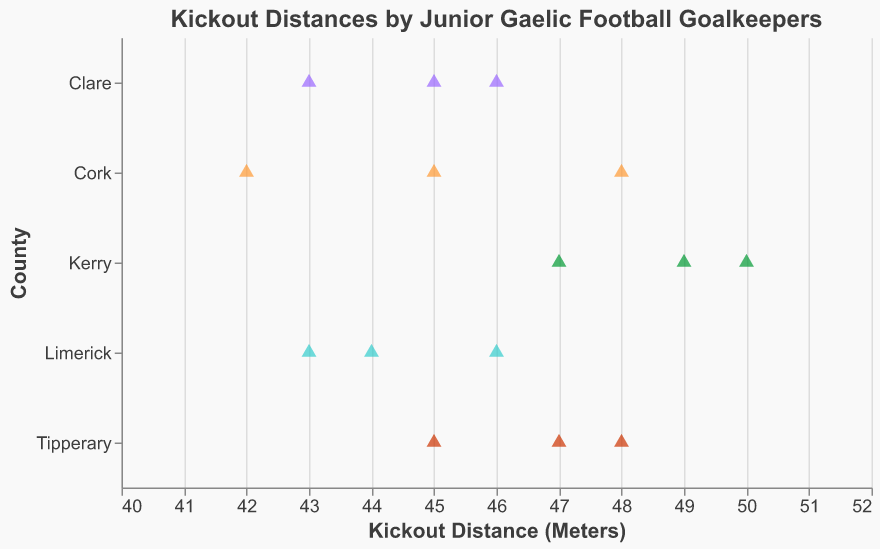What is the title of the figure? The title is located at the top of the figure and it typically describes the content of the plot. In this plot, the title is "Kickout Distances by Junior Gaelic Football Goalkeepers".
Answer: Kickout Distances by Junior Gaelic Football Goalkeepers Which goalkeeper has the longest kickout distance, and what is that distance? To identify the goalkeeper with the longest kickout distance, find the highest data point in terms of kickout distance on the x-axis. Shane Murphy from Kerry has the longest kickout distance at 50 meters.
Answer: Shane Murphy, 50 meters How many goalkeepers are representing Cork in the figure? Count the number of data points that are color-coded and labeled as belonging to Cork. There are three goalkeepers from Cork: Rory Maguire, Sean O'Donoghue, and Cathal Foley.
Answer: 3 What is the range of kickout distances for goalkeepers from Tipperary? Identify the maximum and minimum values of the kickout distances for Tipperary's goalkeepers. The maximum is 48 meters (Jack Lonergam) and the minimum is 45 meters (Shane O'Connell), so the range is 48 - 45 = 3 meters.
Answer: 3 meters Which counties have goalkeepers with a kickout distance of 46 meters? Look at the data points labeled with a 46-meter kickout distance and identify their respective counties. Goalkeepers from Limerick (James Brouder) and Clare (Tristan O'Callaghan) have kickout distances of 46 meters.
Answer: Limerick, Clare Compare the average kickout distances of goalkeepers from Kerry and Clare. Which county has a higher average and by how much? Calculate the average for each county. Kerry: (50 + 47 + 49) / 3 = 48.67 meters. Clare: (46 + 43 + 45) / 3 = 44.67 meters. Kerry has a higher average by 48.67 - 44.67 = 4 meters.
Answer: Kerry, 4 meters Which county has the smallest spread of kickout distances among its goalkeepers? Determine the spread for each county by subtracting the minimum distance from the maximum distance for each county’s goalkeepers. Cork: 48 - 42 = 6 meters. Kerry: 50 - 47 = 3 meters. Limerick: 46 - 43 = 3 meters. Tipperary: 48 - 45 = 3 meters. Clare: 46 - 43 = 3 meters. Multiple counties (Kerry, Limerick, Tipperary, Clare) have the smallest spread of 3 meters.
Answer: Kerry, Limerick, Tipperary, Clare Are there any counties with identical kickout distances reported by any of their goalkeepers? Check for matching kickout distance values within each county. No county has repeat kickout distances among its goalkeepers.
Answer: No In the figure, which shape is used to represent the data points? Identify the shape used to mark the data points on the plot. The shape used in this figure is a triangle.
Answer: Triangle 